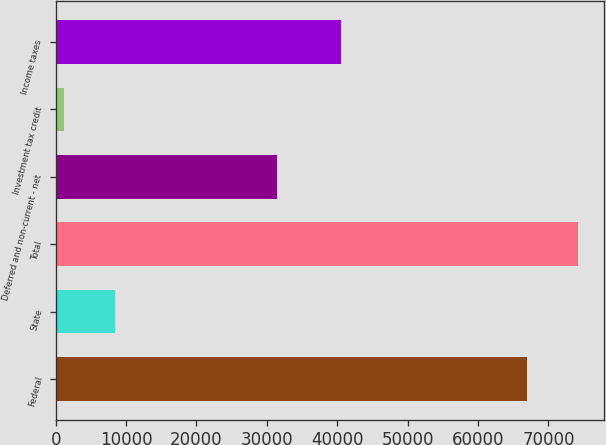Convert chart. <chart><loc_0><loc_0><loc_500><loc_500><bar_chart><fcel>Federal<fcel>State<fcel>Total<fcel>Deferred and non-current - net<fcel>Investment tax credit<fcel>Income taxes<nl><fcel>66966<fcel>8427.4<fcel>74166.4<fcel>31463<fcel>1227<fcel>40541<nl></chart> 